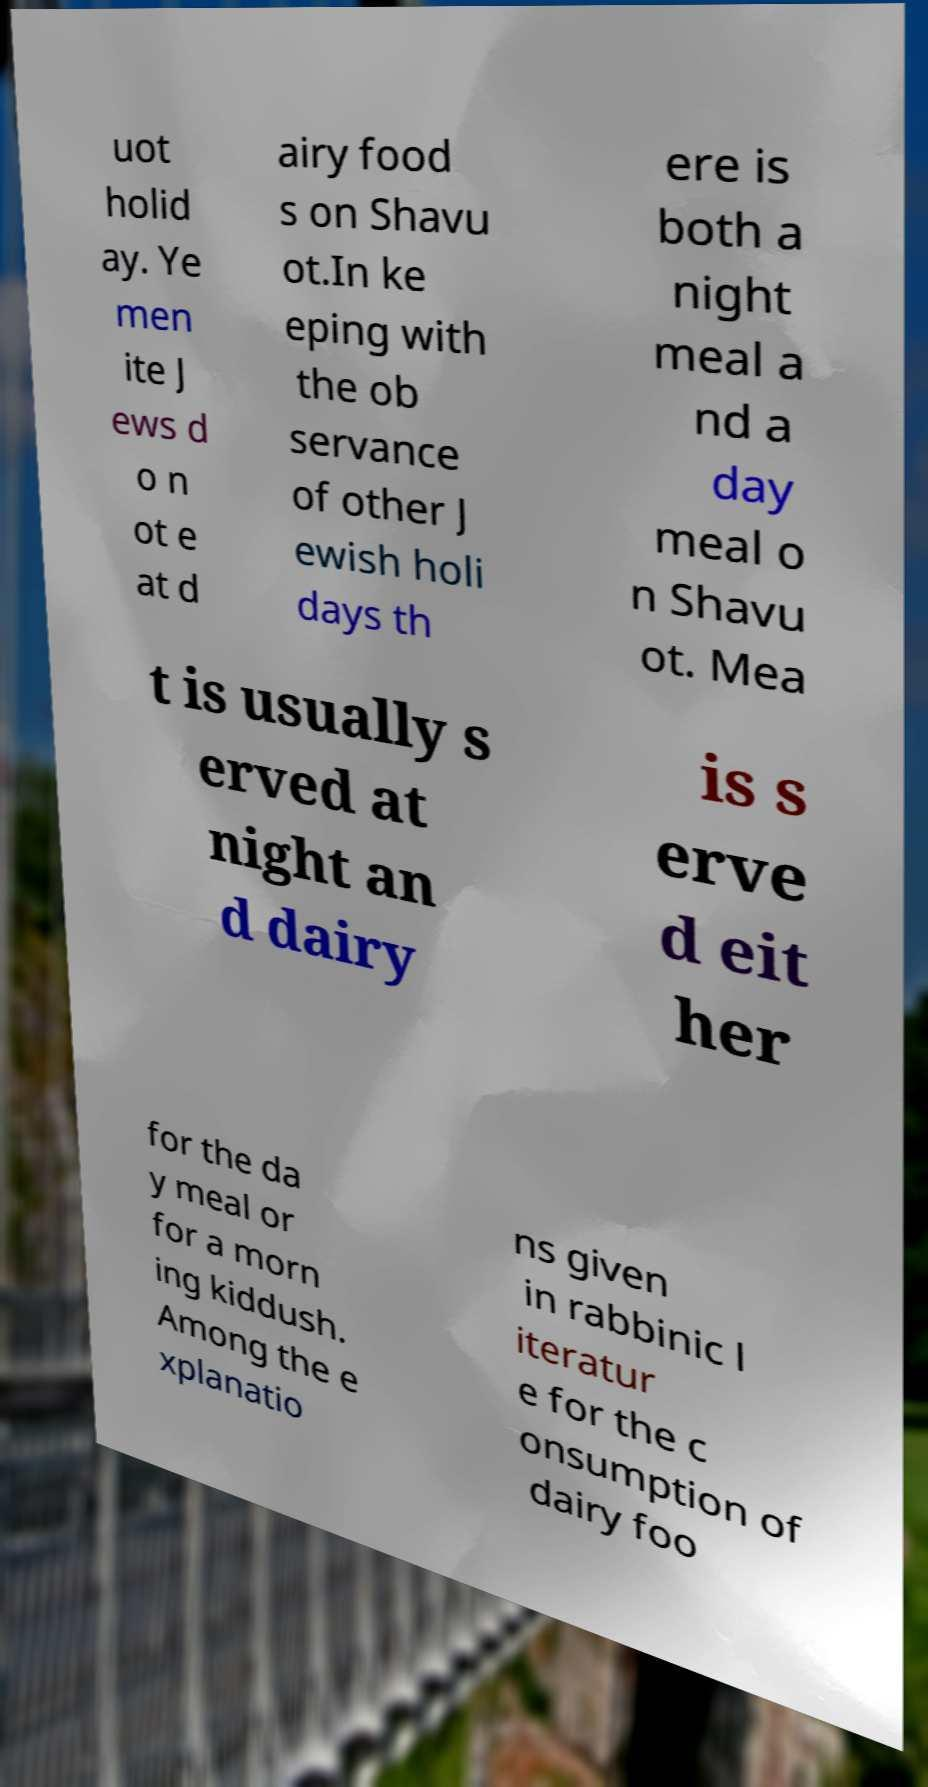Please identify and transcribe the text found in this image. uot holid ay. Ye men ite J ews d o n ot e at d airy food s on Shavu ot.In ke eping with the ob servance of other J ewish holi days th ere is both a night meal a nd a day meal o n Shavu ot. Mea t is usually s erved at night an d dairy is s erve d eit her for the da y meal or for a morn ing kiddush. Among the e xplanatio ns given in rabbinic l iteratur e for the c onsumption of dairy foo 